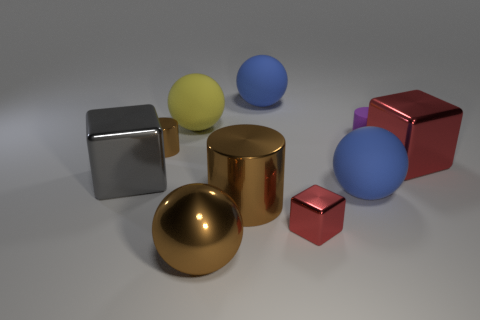Subtract all large shiny cubes. How many cubes are left? 1 Subtract all brown spheres. How many spheres are left? 3 Subtract 2 cubes. How many cubes are left? 1 Subtract all red blocks. Subtract all gray cylinders. How many blocks are left? 1 Subtract all cyan cylinders. How many yellow blocks are left? 0 Subtract all small red metallic cylinders. Subtract all large brown cylinders. How many objects are left? 9 Add 2 tiny purple cylinders. How many tiny purple cylinders are left? 3 Add 4 small green metallic balls. How many small green metallic balls exist? 4 Subtract 0 green balls. How many objects are left? 10 Subtract all spheres. How many objects are left? 6 